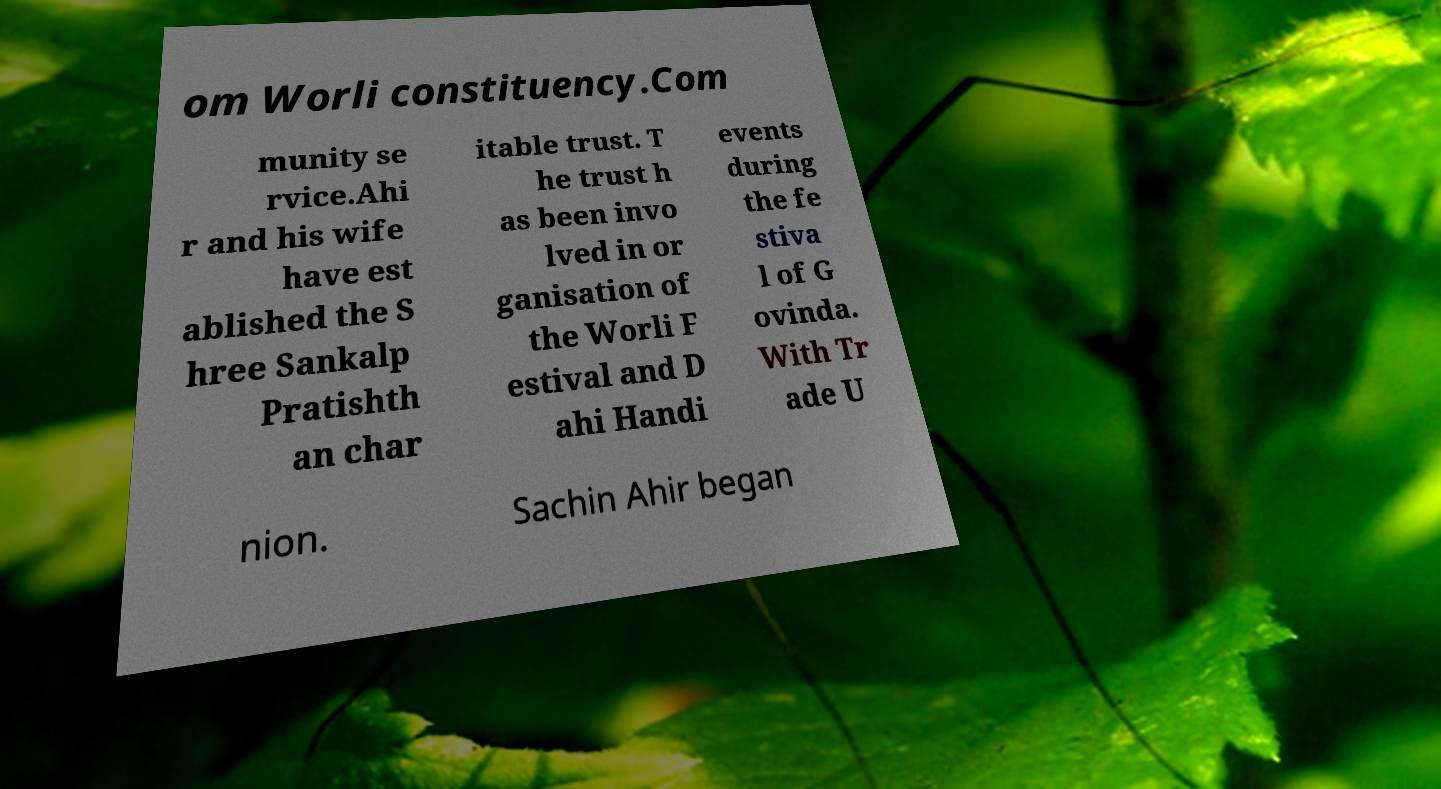For documentation purposes, I need the text within this image transcribed. Could you provide that? om Worli constituency.Com munity se rvice.Ahi r and his wife have est ablished the S hree Sankalp Pratishth an char itable trust. T he trust h as been invo lved in or ganisation of the Worli F estival and D ahi Handi events during the fe stiva l of G ovinda. With Tr ade U nion. Sachin Ahir began 